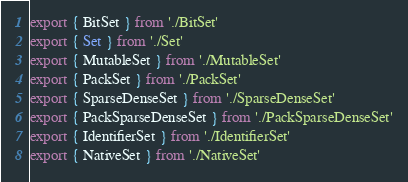Convert code to text. <code><loc_0><loc_0><loc_500><loc_500><_TypeScript_>export { BitSet } from './BitSet'
export { Set } from './Set'
export { MutableSet } from './MutableSet'
export { PackSet } from './PackSet'
export { SparseDenseSet } from './SparseDenseSet'
export { PackSparseDenseSet } from './PackSparseDenseSet'
export { IdentifierSet } from './IdentifierSet'
export { NativeSet } from './NativeSet'
</code> 